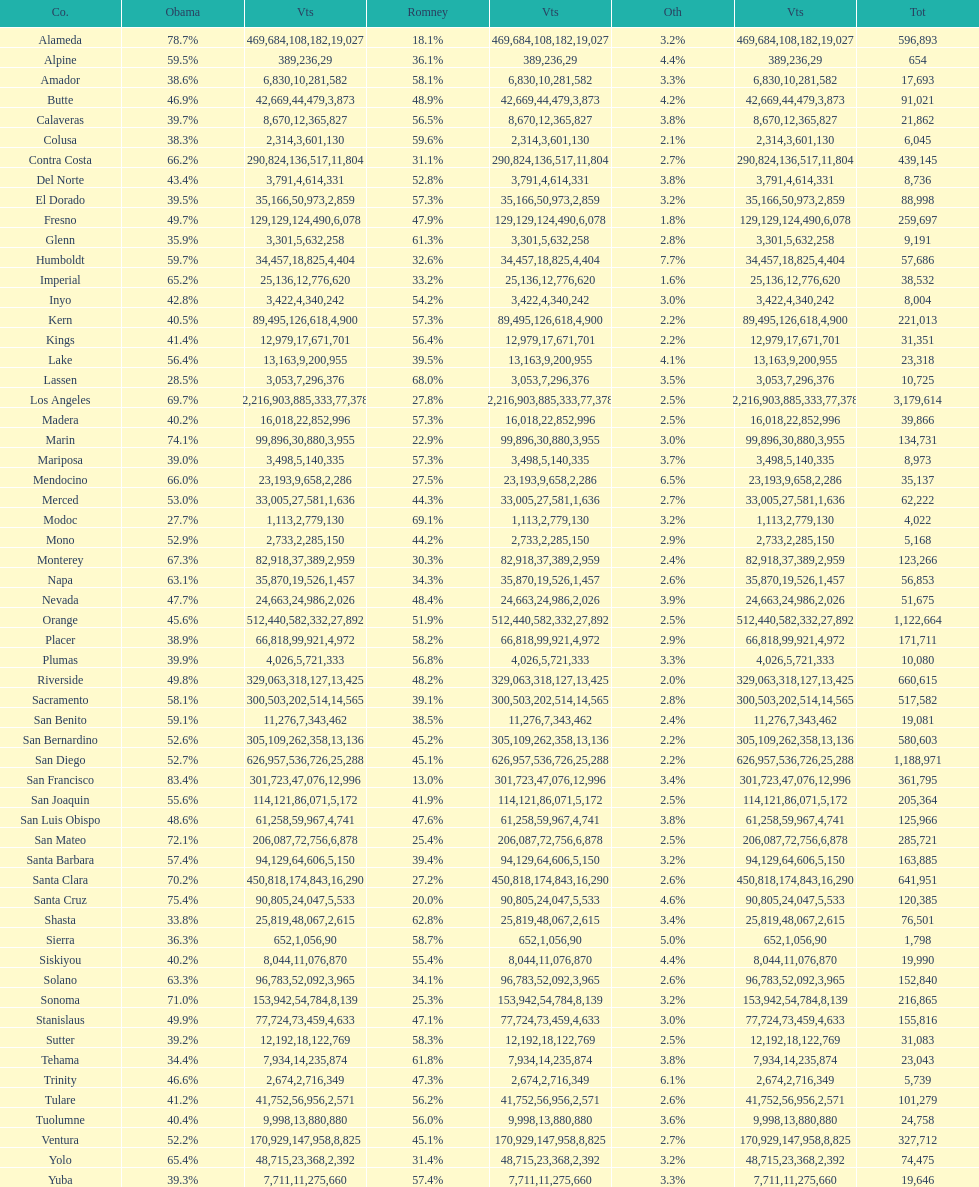What is the total number of votes for amador? 17693. 